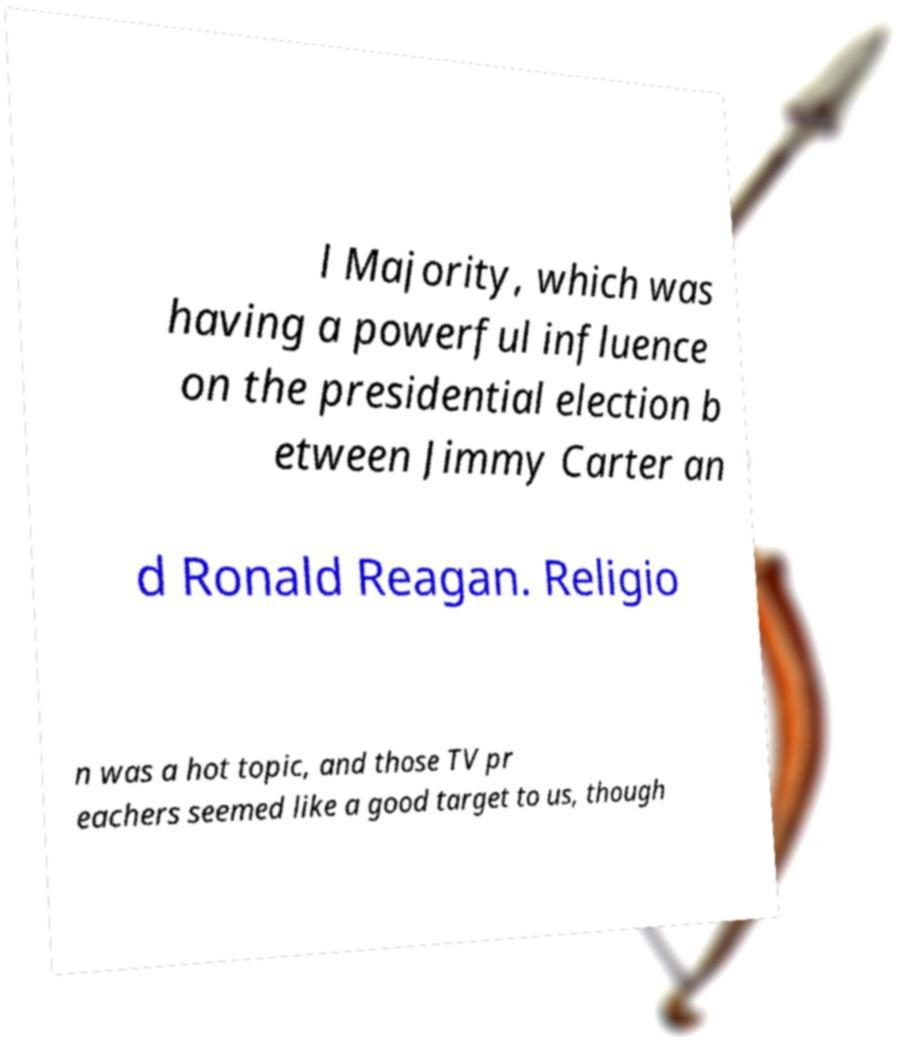Can you accurately transcribe the text from the provided image for me? l Majority, which was having a powerful influence on the presidential election b etween Jimmy Carter an d Ronald Reagan. Religio n was a hot topic, and those TV pr eachers seemed like a good target to us, though 